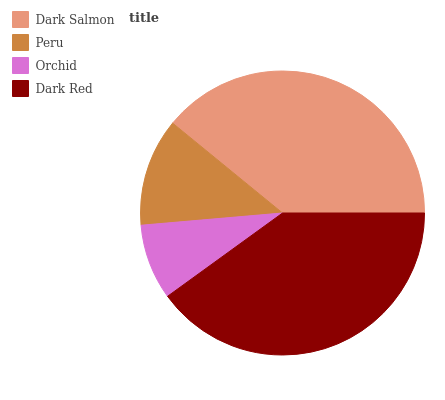Is Orchid the minimum?
Answer yes or no. Yes. Is Dark Red the maximum?
Answer yes or no. Yes. Is Peru the minimum?
Answer yes or no. No. Is Peru the maximum?
Answer yes or no. No. Is Dark Salmon greater than Peru?
Answer yes or no. Yes. Is Peru less than Dark Salmon?
Answer yes or no. Yes. Is Peru greater than Dark Salmon?
Answer yes or no. No. Is Dark Salmon less than Peru?
Answer yes or no. No. Is Dark Salmon the high median?
Answer yes or no. Yes. Is Peru the low median?
Answer yes or no. Yes. Is Peru the high median?
Answer yes or no. No. Is Dark Salmon the low median?
Answer yes or no. No. 